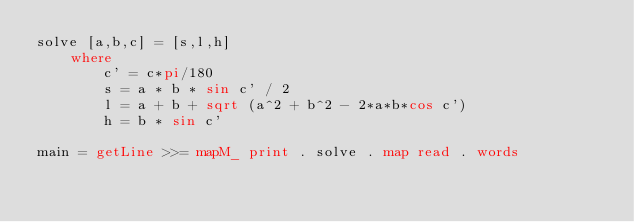<code> <loc_0><loc_0><loc_500><loc_500><_Haskell_>solve [a,b,c] = [s,l,h]
	where 
		c' = c*pi/180
		s = a * b * sin c' / 2
		l = a + b + sqrt (a^2 + b^2 - 2*a*b*cos c')
		h = b * sin c'

main = getLine >>= mapM_ print . solve . map read . words</code> 